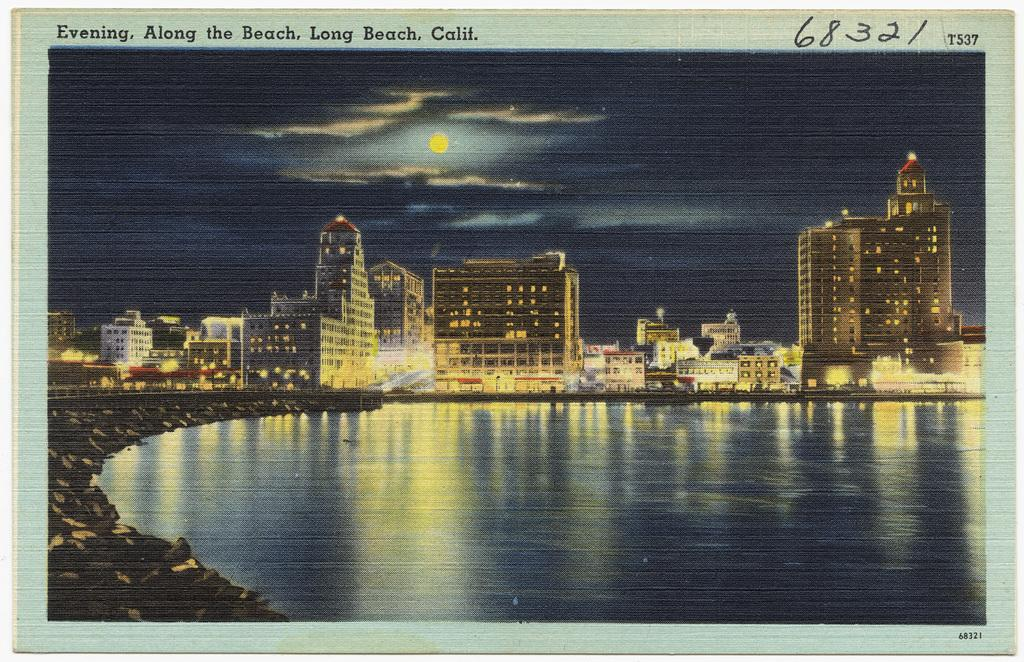What is the main subject of the image? The main subject of the image is a photo of buildings. What else can be seen in the image besides the buildings? Water, rocks, lights, and the sky are visible in the image. Is there any text present in the image? Yes, there is text written at the top and bottom of the image. How does the beam of light interact with the afterthought in the image? There is no beam of light or afterthought present in the image. 